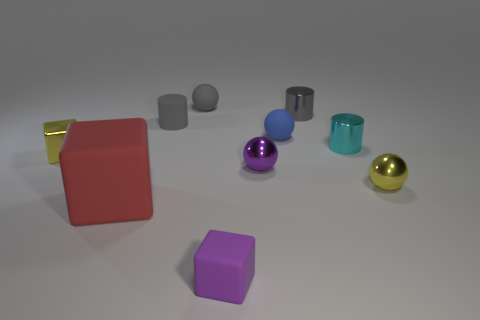The tiny gray object that is to the right of the small rubber thing in front of the yellow metallic sphere is what shape?
Offer a terse response. Cylinder. How many cyan objects are large matte blocks or small blocks?
Your answer should be compact. 0. There is a tiny blue object; are there any gray things right of it?
Ensure brevity in your answer.  Yes. The gray rubber cylinder has what size?
Make the answer very short. Small. What is the size of the other yellow object that is the same shape as the large object?
Offer a terse response. Small. There is a red block in front of the cyan thing; what number of objects are behind it?
Ensure brevity in your answer.  8. Do the tiny yellow thing that is on the left side of the small gray metallic cylinder and the cylinder that is in front of the matte cylinder have the same material?
Ensure brevity in your answer.  Yes. What number of small cyan shiny things are the same shape as the tiny blue thing?
Make the answer very short. 0. How many other rubber cubes have the same color as the small matte block?
Give a very brief answer. 0. Is the shape of the tiny shiny thing that is behind the blue rubber thing the same as the tiny cyan thing to the right of the big red matte block?
Keep it short and to the point. Yes. 